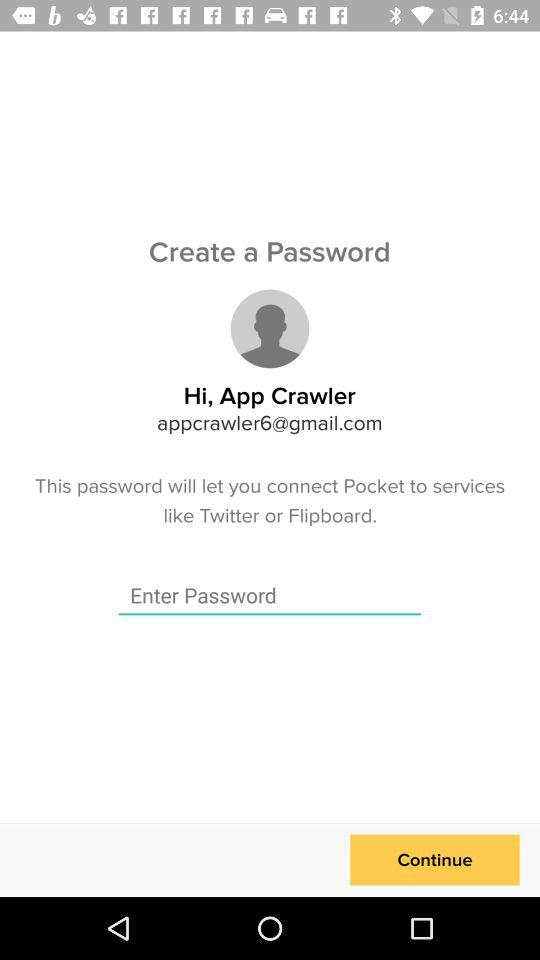What is the name of the user? The name of the user is App Crawler. 